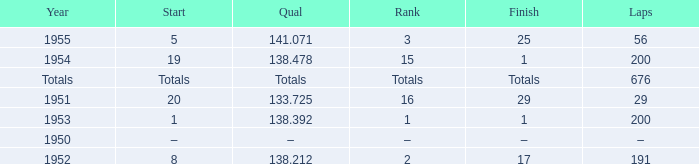Parse the table in full. {'header': ['Year', 'Start', 'Qual', 'Rank', 'Finish', 'Laps'], 'rows': [['1955', '5', '141.071', '3', '25', '56'], ['1954', '19', '138.478', '15', '1', '200'], ['Totals', 'Totals', 'Totals', 'Totals', 'Totals', '676'], ['1951', '20', '133.725', '16', '29', '29'], ['1953', '1', '138.392', '1', '1', '200'], ['1950', '–', '–', '–', '–', '–'], ['1952', '8', '138.212', '2', '17', '191']]} What finish qualified at 141.071? 25.0. 